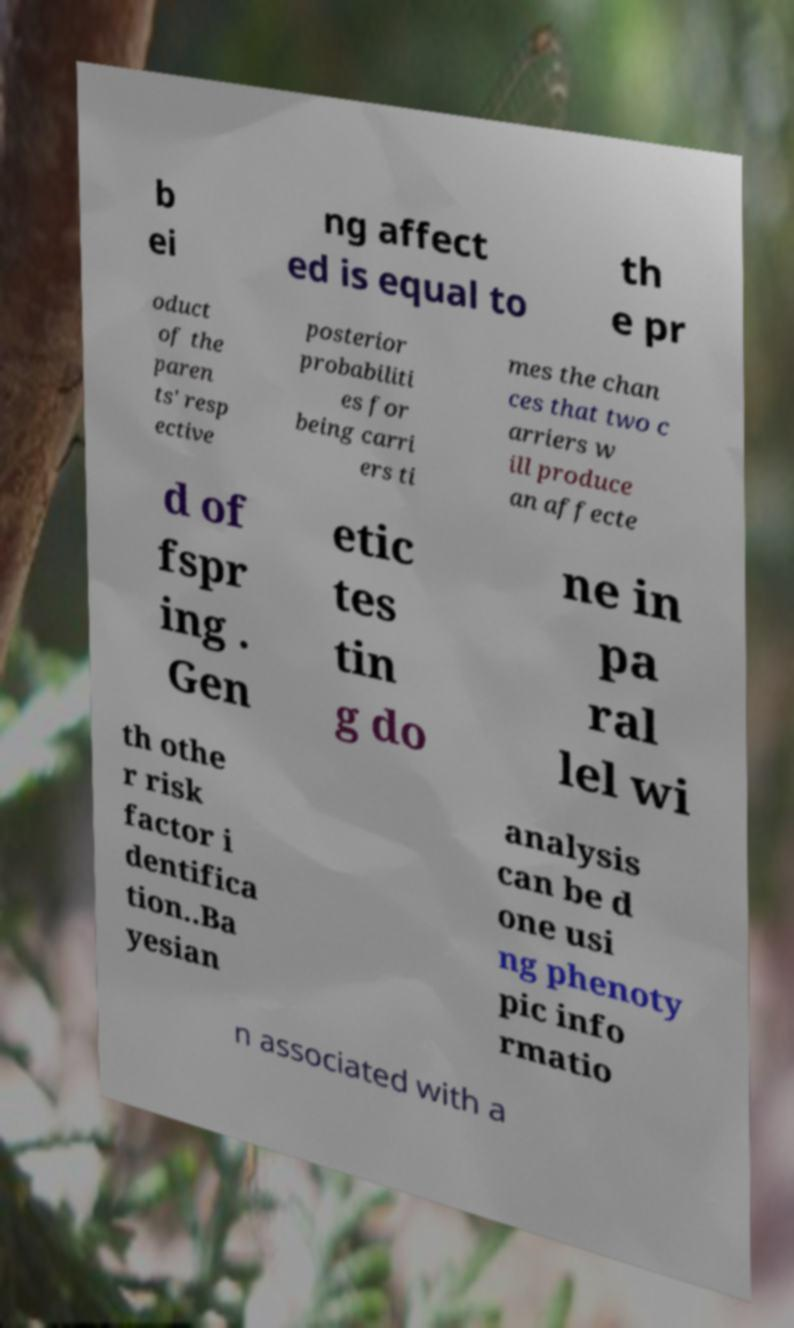I need the written content from this picture converted into text. Can you do that? b ei ng affect ed is equal to th e pr oduct of the paren ts' resp ective posterior probabiliti es for being carri ers ti mes the chan ces that two c arriers w ill produce an affecte d of fspr ing . Gen etic tes tin g do ne in pa ral lel wi th othe r risk factor i dentifica tion..Ba yesian analysis can be d one usi ng phenoty pic info rmatio n associated with a 